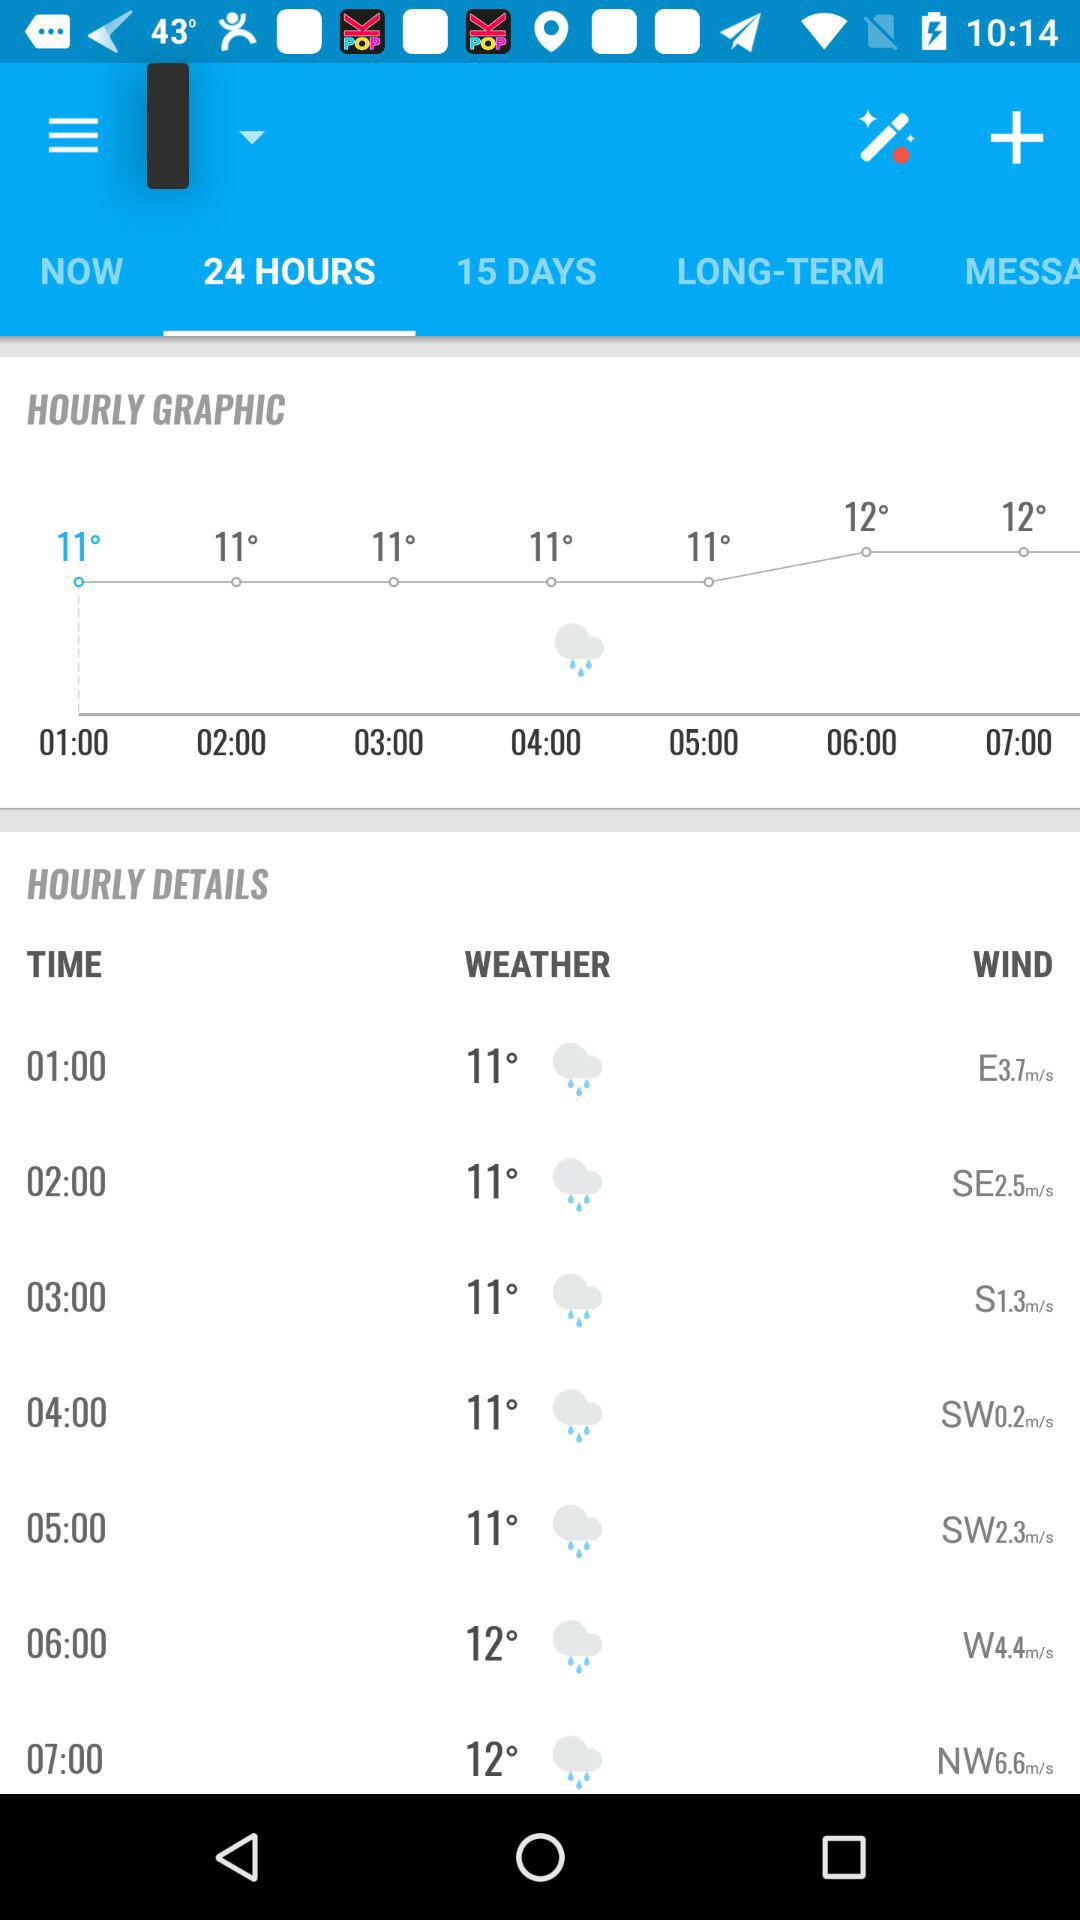What is the wind speed at 01:00?
Answer the question using a single word or phrase. E37.m/s 